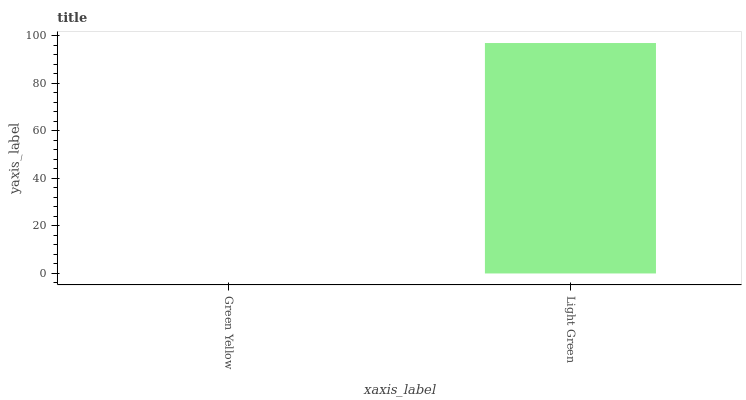Is Green Yellow the minimum?
Answer yes or no. Yes. Is Light Green the maximum?
Answer yes or no. Yes. Is Light Green the minimum?
Answer yes or no. No. Is Light Green greater than Green Yellow?
Answer yes or no. Yes. Is Green Yellow less than Light Green?
Answer yes or no. Yes. Is Green Yellow greater than Light Green?
Answer yes or no. No. Is Light Green less than Green Yellow?
Answer yes or no. No. Is Light Green the high median?
Answer yes or no. Yes. Is Green Yellow the low median?
Answer yes or no. Yes. Is Green Yellow the high median?
Answer yes or no. No. Is Light Green the low median?
Answer yes or no. No. 